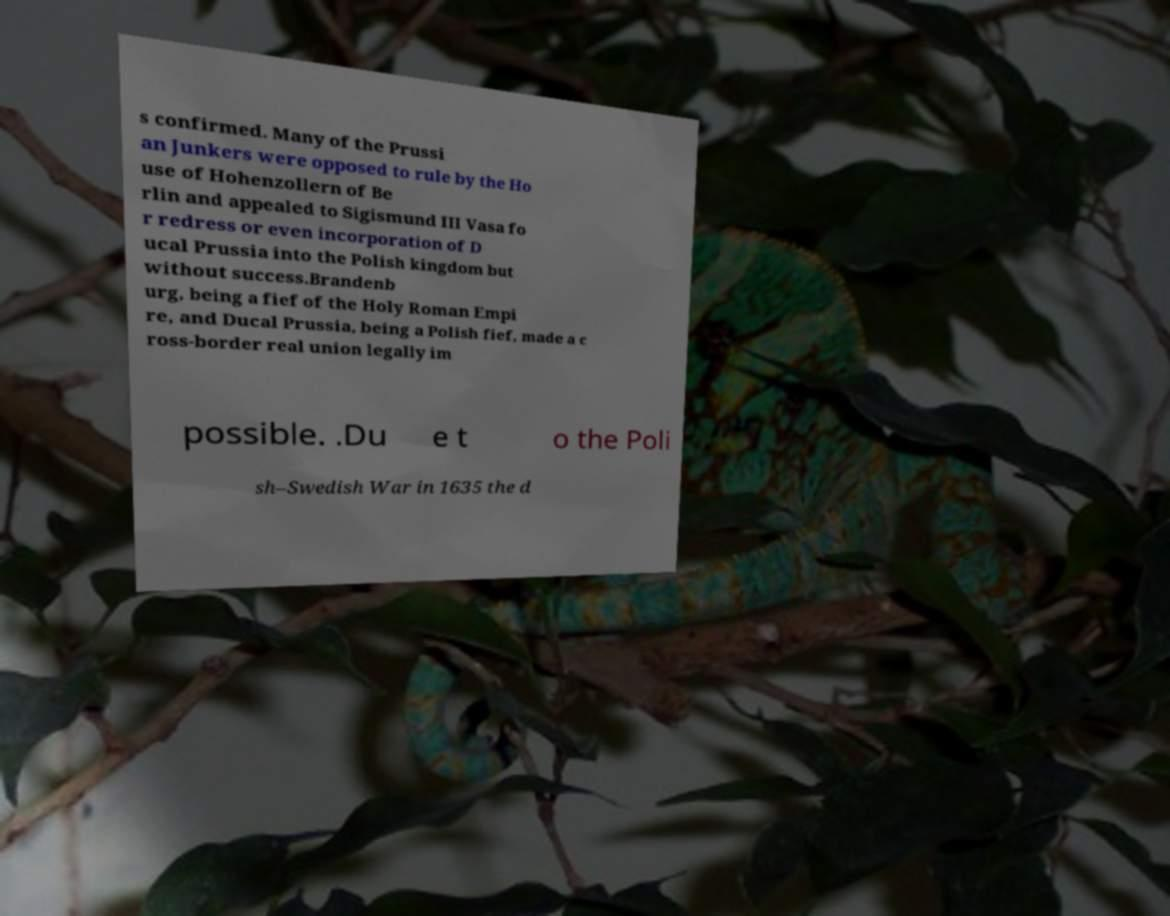There's text embedded in this image that I need extracted. Can you transcribe it verbatim? s confirmed. Many of the Prussi an Junkers were opposed to rule by the Ho use of Hohenzollern of Be rlin and appealed to Sigismund III Vasa fo r redress or even incorporation of D ucal Prussia into the Polish kingdom but without success.Brandenb urg, being a fief of the Holy Roman Empi re, and Ducal Prussia, being a Polish fief, made a c ross-border real union legally im possible. .Du e t o the Poli sh–Swedish War in 1635 the d 